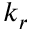<formula> <loc_0><loc_0><loc_500><loc_500>k _ { r }</formula> 